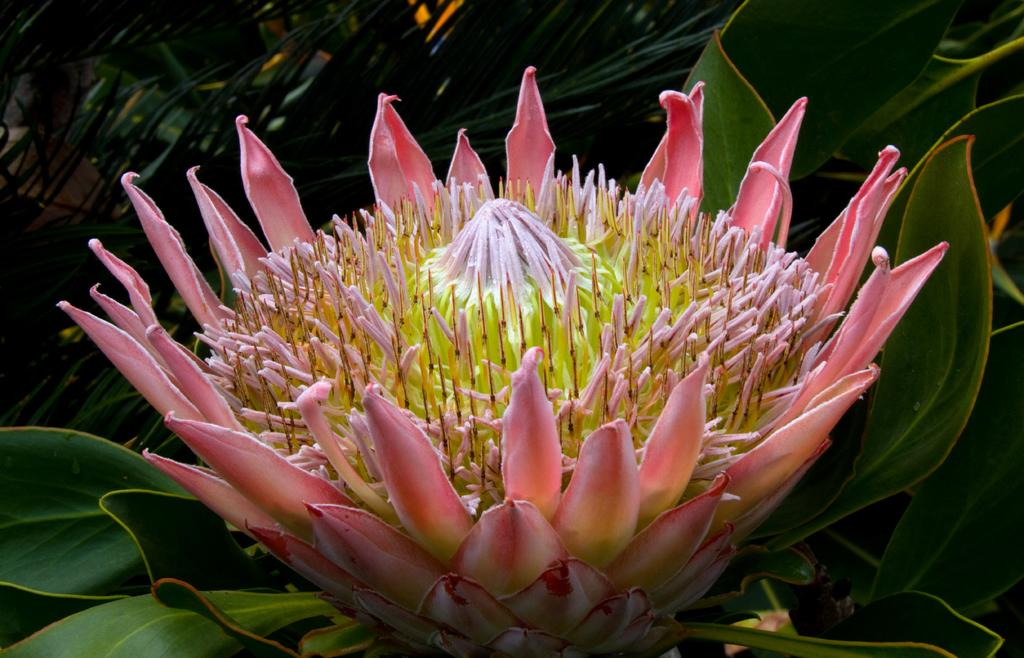What type of plant can be seen in the image? There is a flower visible in the image. What else is present in the image besides the flower? There are leaves in the image. Can you describe the background of the image? There is a plant in the background of the image. How many potatoes are visible in the image? There are no potatoes present in the image. What type of crate is used to store the flowers in the image? There is no crate visible in the image. 